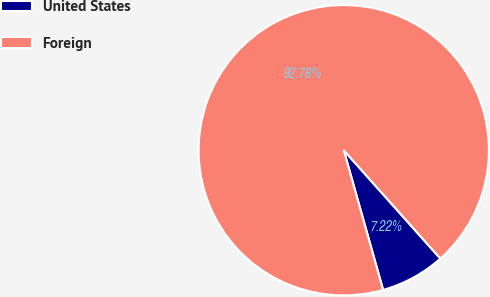Convert chart. <chart><loc_0><loc_0><loc_500><loc_500><pie_chart><fcel>United States<fcel>Foreign<nl><fcel>7.22%<fcel>92.78%<nl></chart> 